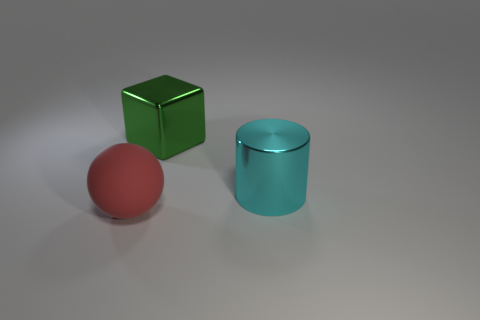Add 3 large cyan cylinders. How many objects exist? 6 Subtract all cylinders. How many objects are left? 2 Subtract all green shiny blocks. Subtract all small cyan cylinders. How many objects are left? 2 Add 3 red rubber spheres. How many red rubber spheres are left? 4 Add 1 large green shiny objects. How many large green shiny objects exist? 2 Subtract 0 purple cubes. How many objects are left? 3 